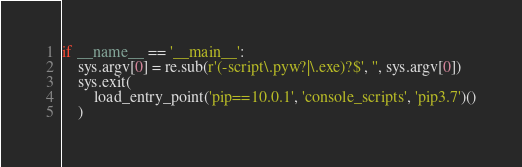<code> <loc_0><loc_0><loc_500><loc_500><_Python_>if __name__ == '__main__':
    sys.argv[0] = re.sub(r'(-script\.pyw?|\.exe)?$', '', sys.argv[0])
    sys.exit(
        load_entry_point('pip==10.0.1', 'console_scripts', 'pip3.7')()
    )
</code> 